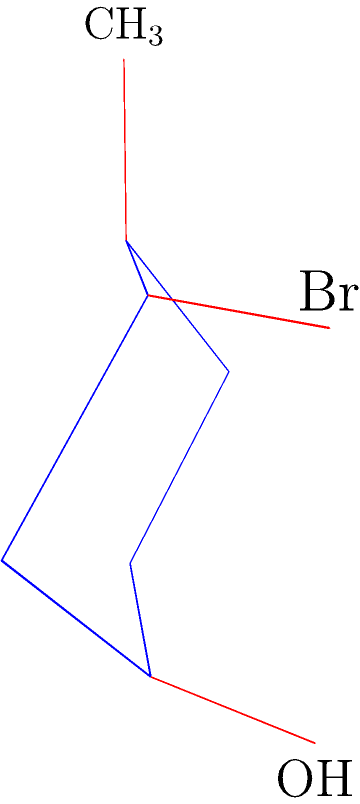Determine the most stable chair conformation of 1-bromo-1-hydroxy-3-methylcyclohexane. Which substituents are in equatorial positions, and which are in axial positions? To determine the most stable chair conformation, we need to follow these steps:

1. Identify the substituents: We have three substituents - CH$_3$, Br, and OH.

2. Assess the size and priority of substituents:
   - CH$_3$ is relatively large
   - Br is large
   - OH is medium-sized

3. Apply the rule: Larger substituents prefer equatorial positions to minimize 1,3-diaxial interactions.

4. Analyze the given chair conformation:
   - CH$_3$ is in an equatorial position
   - Br is in an equatorial position
   - OH is in an axial position

5. Evaluate stability:
   - Having the two larger substituents (CH$_3$ and Br) in equatorial positions is favorable
   - The OH group in the axial position is less favorable, but it's the best compromise

6. Consider the alternative conformation:
   - Flipping the chair would put both CH$_3$ and Br in axial positions, which would be less stable due to increased 1,3-diaxial interactions

Therefore, the given chair conformation is the most stable one, with:
- CH$_3$ in equatorial position
- Br in equatorial position
- OH in axial position
Answer: CH$_3$ (eq), Br (eq), OH (ax) 